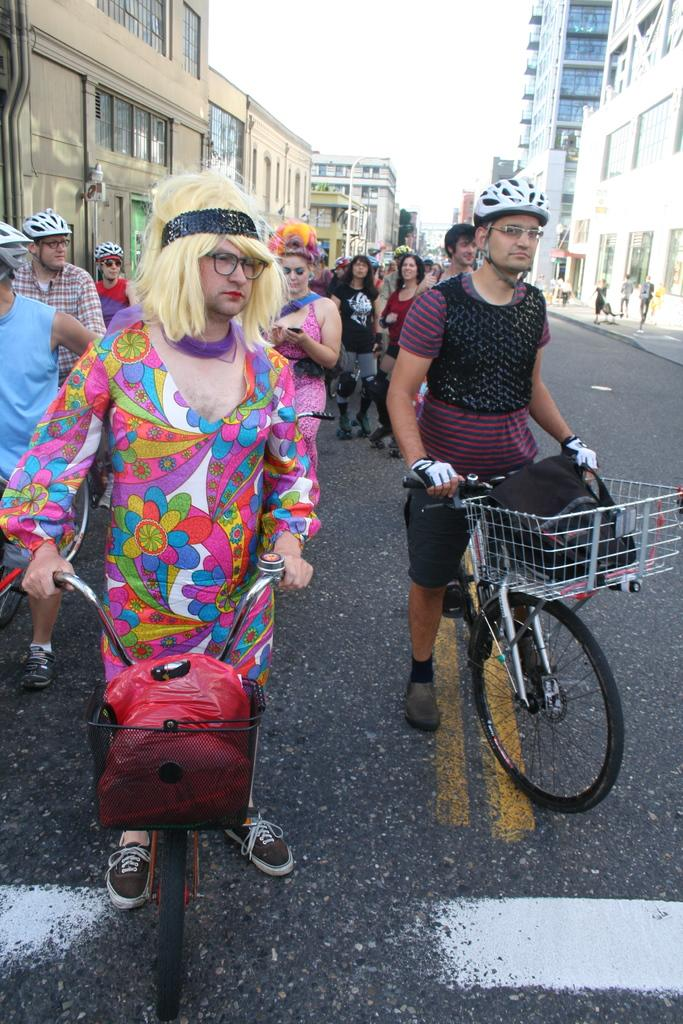What is happening in the image involving a group of people? The group of people are riding a bicycle. How many people are involved in this activity? The number of people is not specified, but there is a group of people riding the bicycle. What can be seen in the background of the image? There are buildings in the background of the image. What type of mitten is being used by the people riding the bicycle in the image? There is no mention of mittens in the image; the people are riding a bicycle without any gloves or mittens. How many pigs are present in the image? There are no pigs present in the image; it features a group of people riding a bicycle with buildings in the background. 